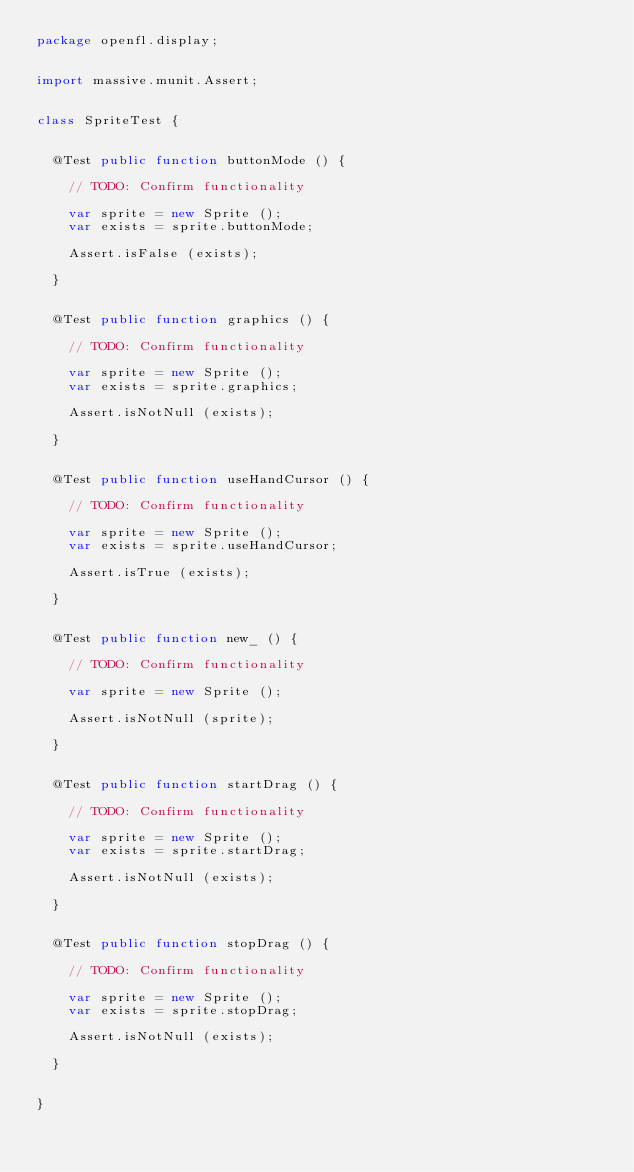<code> <loc_0><loc_0><loc_500><loc_500><_Haxe_>package openfl.display;


import massive.munit.Assert;


class SpriteTest {
	
	
	@Test public function buttonMode () {
		
		// TODO: Confirm functionality
		
		var sprite = new Sprite ();
		var exists = sprite.buttonMode;
		
		Assert.isFalse (exists);
		
	}
	
	
	@Test public function graphics () {
		
		// TODO: Confirm functionality
		
		var sprite = new Sprite ();
		var exists = sprite.graphics;
		
		Assert.isNotNull (exists);
		
	}
	
	
	@Test public function useHandCursor () {
		
		// TODO: Confirm functionality
		
		var sprite = new Sprite ();
		var exists = sprite.useHandCursor;
		
		Assert.isTrue (exists);
		
	}
	
	
	@Test public function new_ () {
		
		// TODO: Confirm functionality
		
		var sprite = new Sprite ();
		
		Assert.isNotNull (sprite);
		
	}
	
	
	@Test public function startDrag () {
		
		// TODO: Confirm functionality
		
		var sprite = new Sprite ();
		var exists = sprite.startDrag;
		
		Assert.isNotNull (exists);
		
	}
	
	
	@Test public function stopDrag () {
		
		// TODO: Confirm functionality
		
		var sprite = new Sprite ();
		var exists = sprite.stopDrag;
		
		Assert.isNotNull (exists);
		
	}
	
	
}</code> 